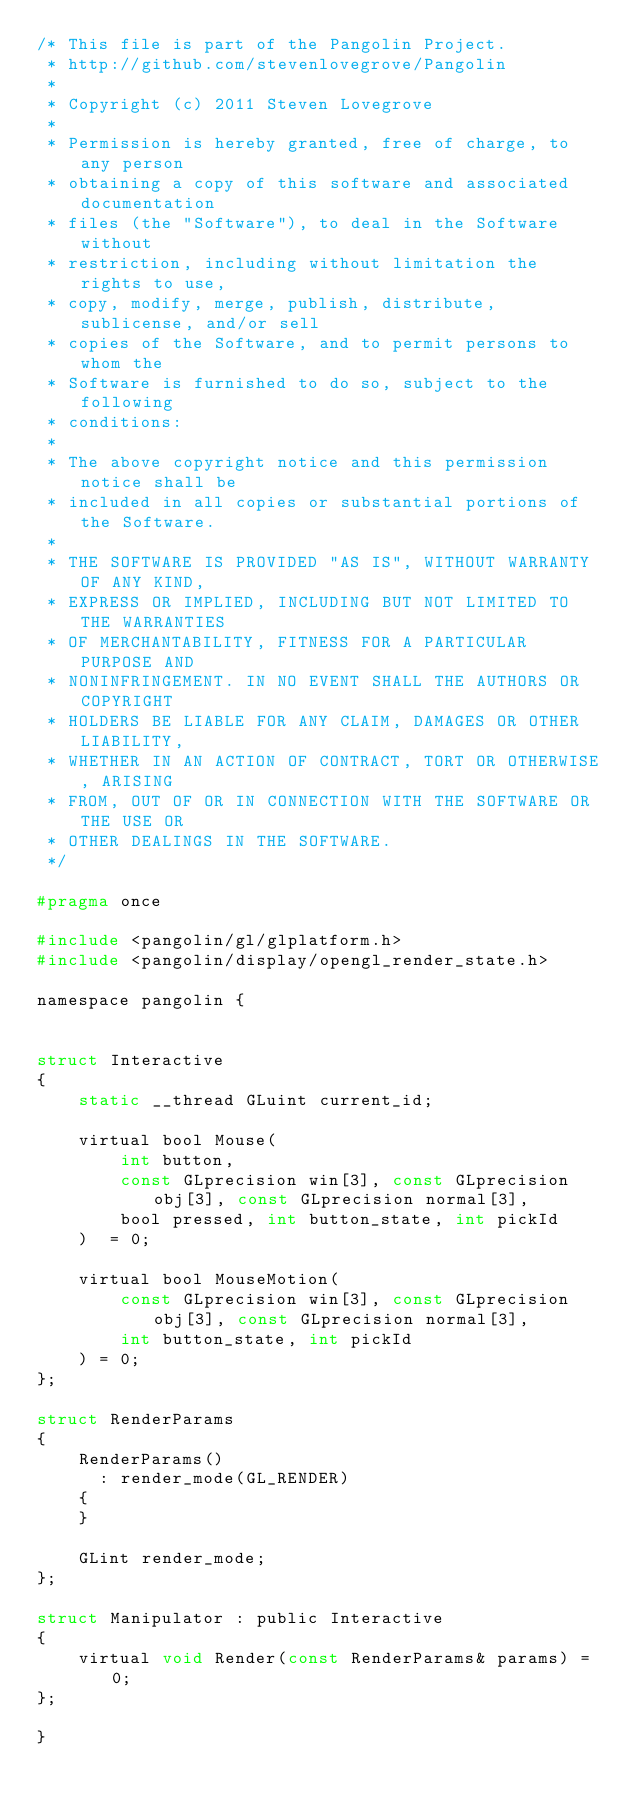<code> <loc_0><loc_0><loc_500><loc_500><_C_>/* This file is part of the Pangolin Project.
 * http://github.com/stevenlovegrove/Pangolin
 *
 * Copyright (c) 2011 Steven Lovegrove
 *
 * Permission is hereby granted, free of charge, to any person
 * obtaining a copy of this software and associated documentation
 * files (the "Software"), to deal in the Software without
 * restriction, including without limitation the rights to use,
 * copy, modify, merge, publish, distribute, sublicense, and/or sell
 * copies of the Software, and to permit persons to whom the
 * Software is furnished to do so, subject to the following
 * conditions:
 *
 * The above copyright notice and this permission notice shall be
 * included in all copies or substantial portions of the Software.
 *
 * THE SOFTWARE IS PROVIDED "AS IS", WITHOUT WARRANTY OF ANY KIND,
 * EXPRESS OR IMPLIED, INCLUDING BUT NOT LIMITED TO THE WARRANTIES
 * OF MERCHANTABILITY, FITNESS FOR A PARTICULAR PURPOSE AND
 * NONINFRINGEMENT. IN NO EVENT SHALL THE AUTHORS OR COPYRIGHT
 * HOLDERS BE LIABLE FOR ANY CLAIM, DAMAGES OR OTHER LIABILITY,
 * WHETHER IN AN ACTION OF CONTRACT, TORT OR OTHERWISE, ARISING
 * FROM, OUT OF OR IN CONNECTION WITH THE SOFTWARE OR THE USE OR
 * OTHER DEALINGS IN THE SOFTWARE.
 */

#pragma once

#include <pangolin/gl/glplatform.h>
#include <pangolin/display/opengl_render_state.h>

namespace pangolin {


struct Interactive
{
    static __thread GLuint current_id;

    virtual bool Mouse(
        int button,
        const GLprecision win[3], const GLprecision obj[3], const GLprecision normal[3],
        bool pressed, int button_state, int pickId
    )  = 0;

    virtual bool MouseMotion(
        const GLprecision win[3], const GLprecision obj[3], const GLprecision normal[3],
        int button_state, int pickId
    ) = 0;
};

struct RenderParams
{
    RenderParams()
      : render_mode(GL_RENDER)
    {
    }

    GLint render_mode;
};

struct Manipulator : public Interactive
{
    virtual void Render(const RenderParams& params) = 0;
};

}
</code> 